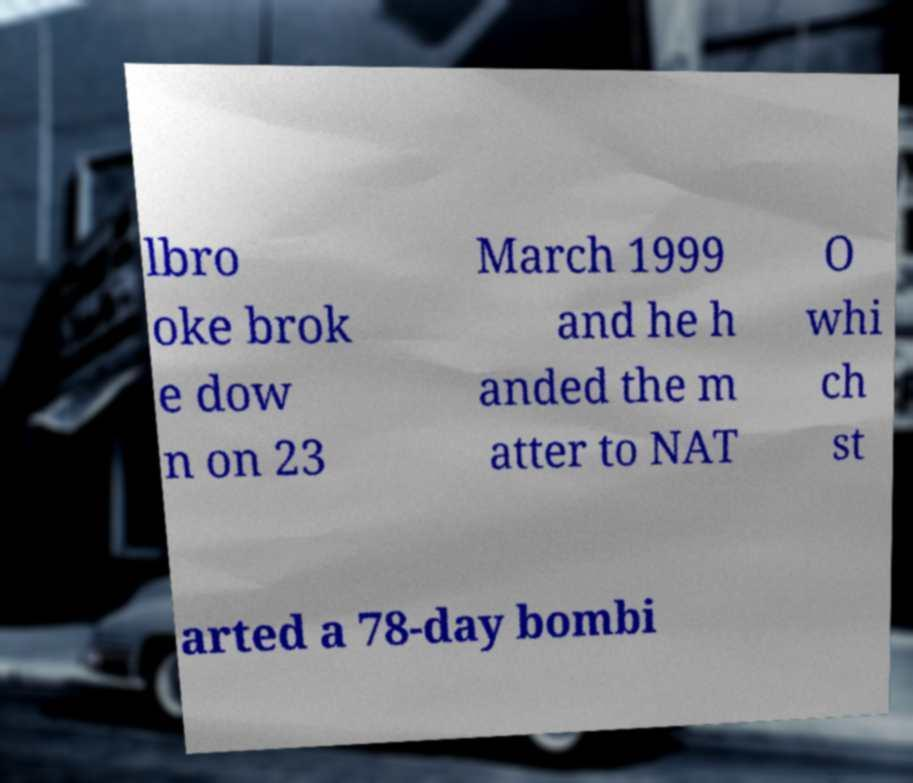What messages or text are displayed in this image? I need them in a readable, typed format. lbro oke brok e dow n on 23 March 1999 and he h anded the m atter to NAT O whi ch st arted a 78-day bombi 